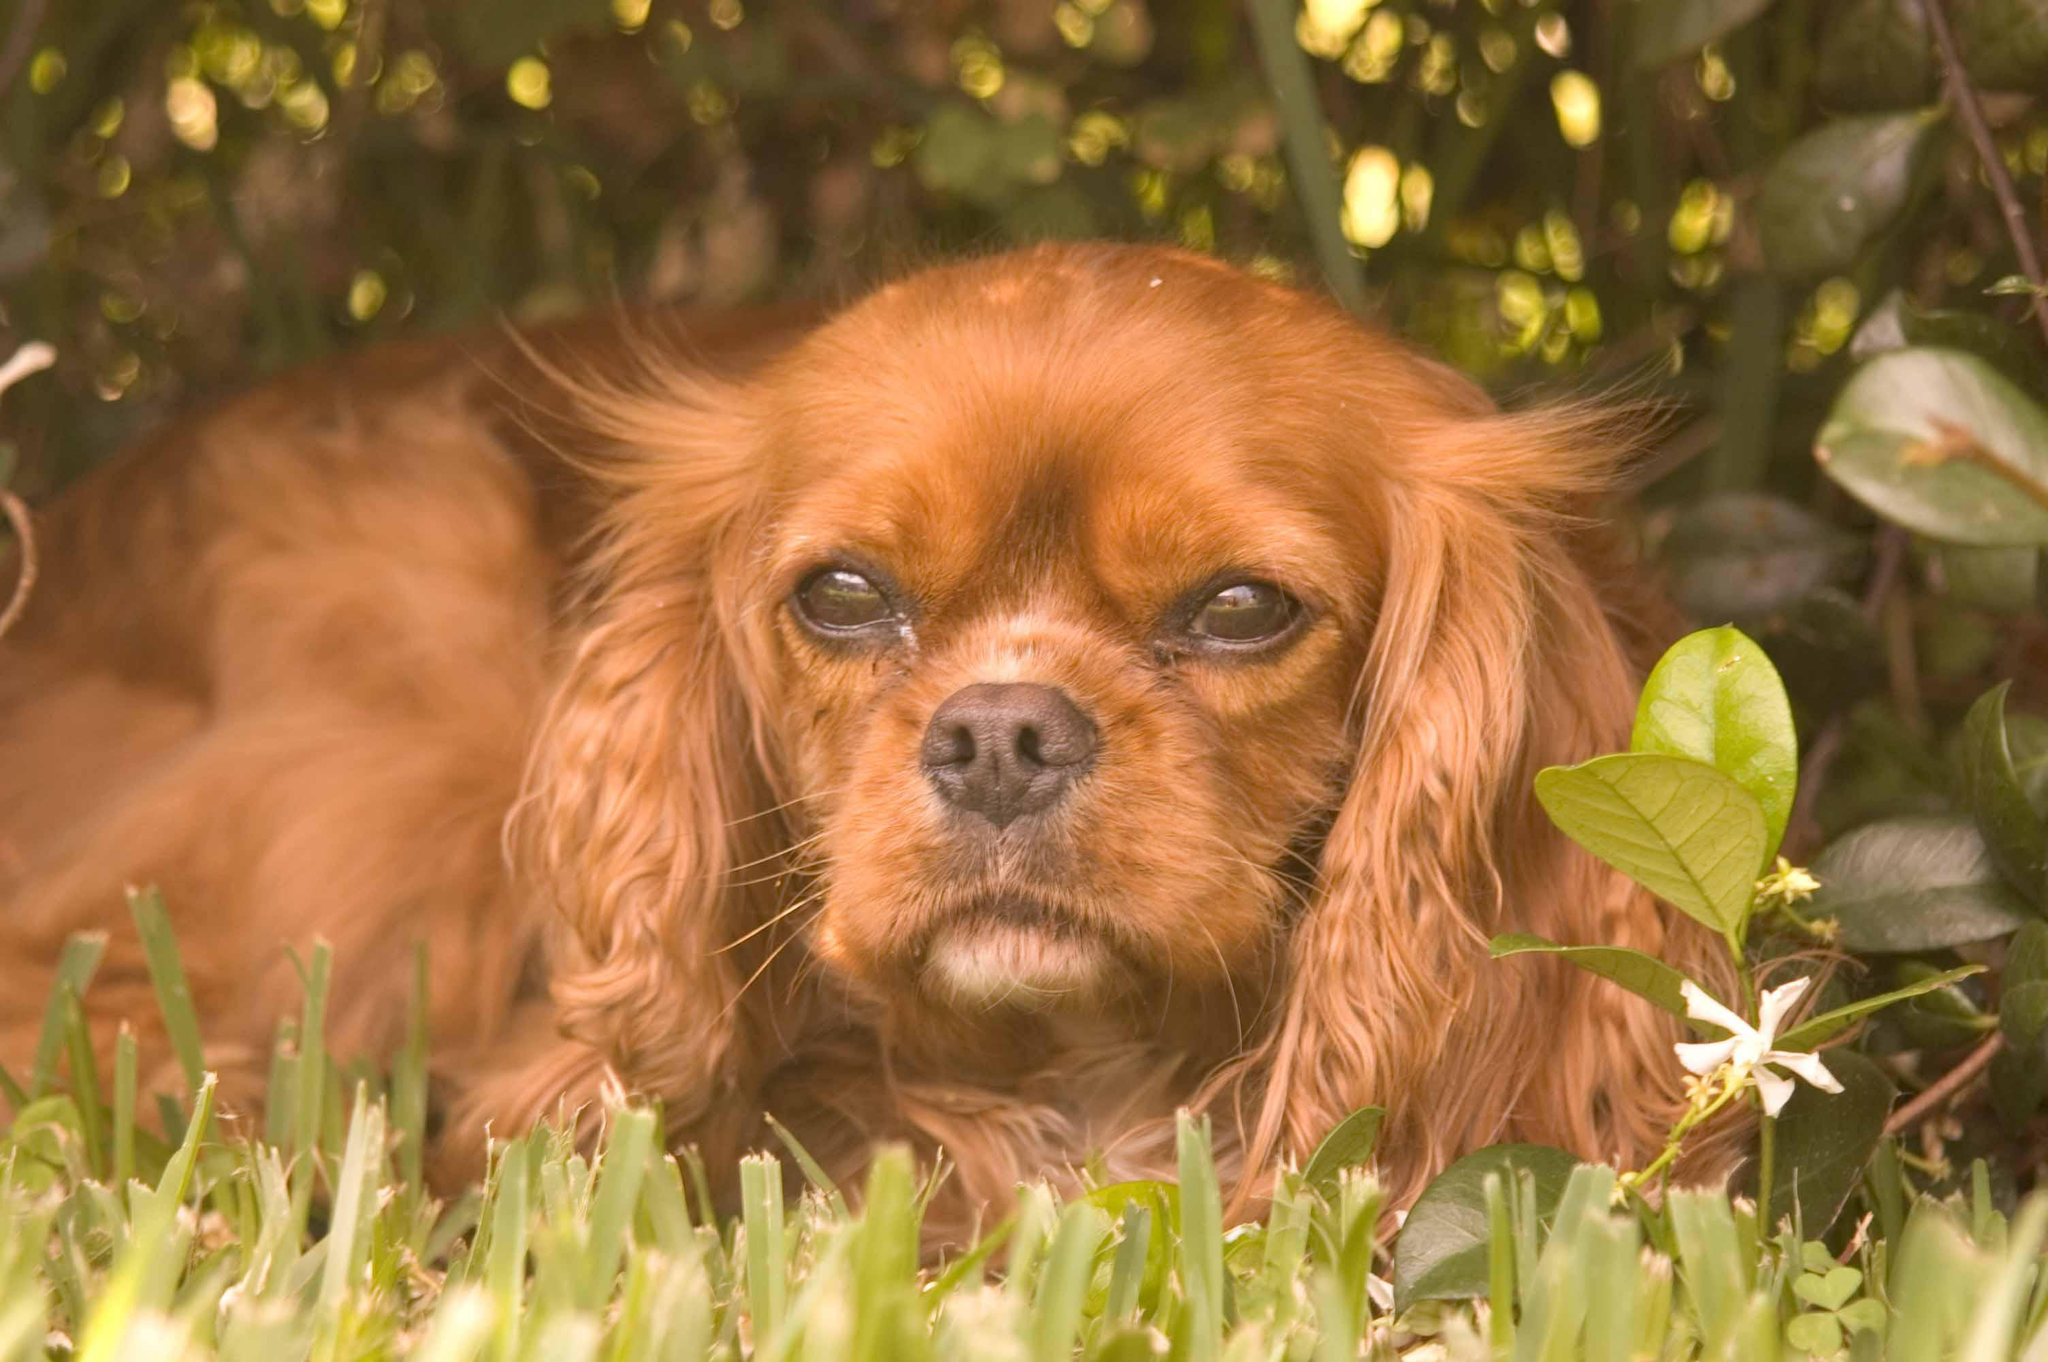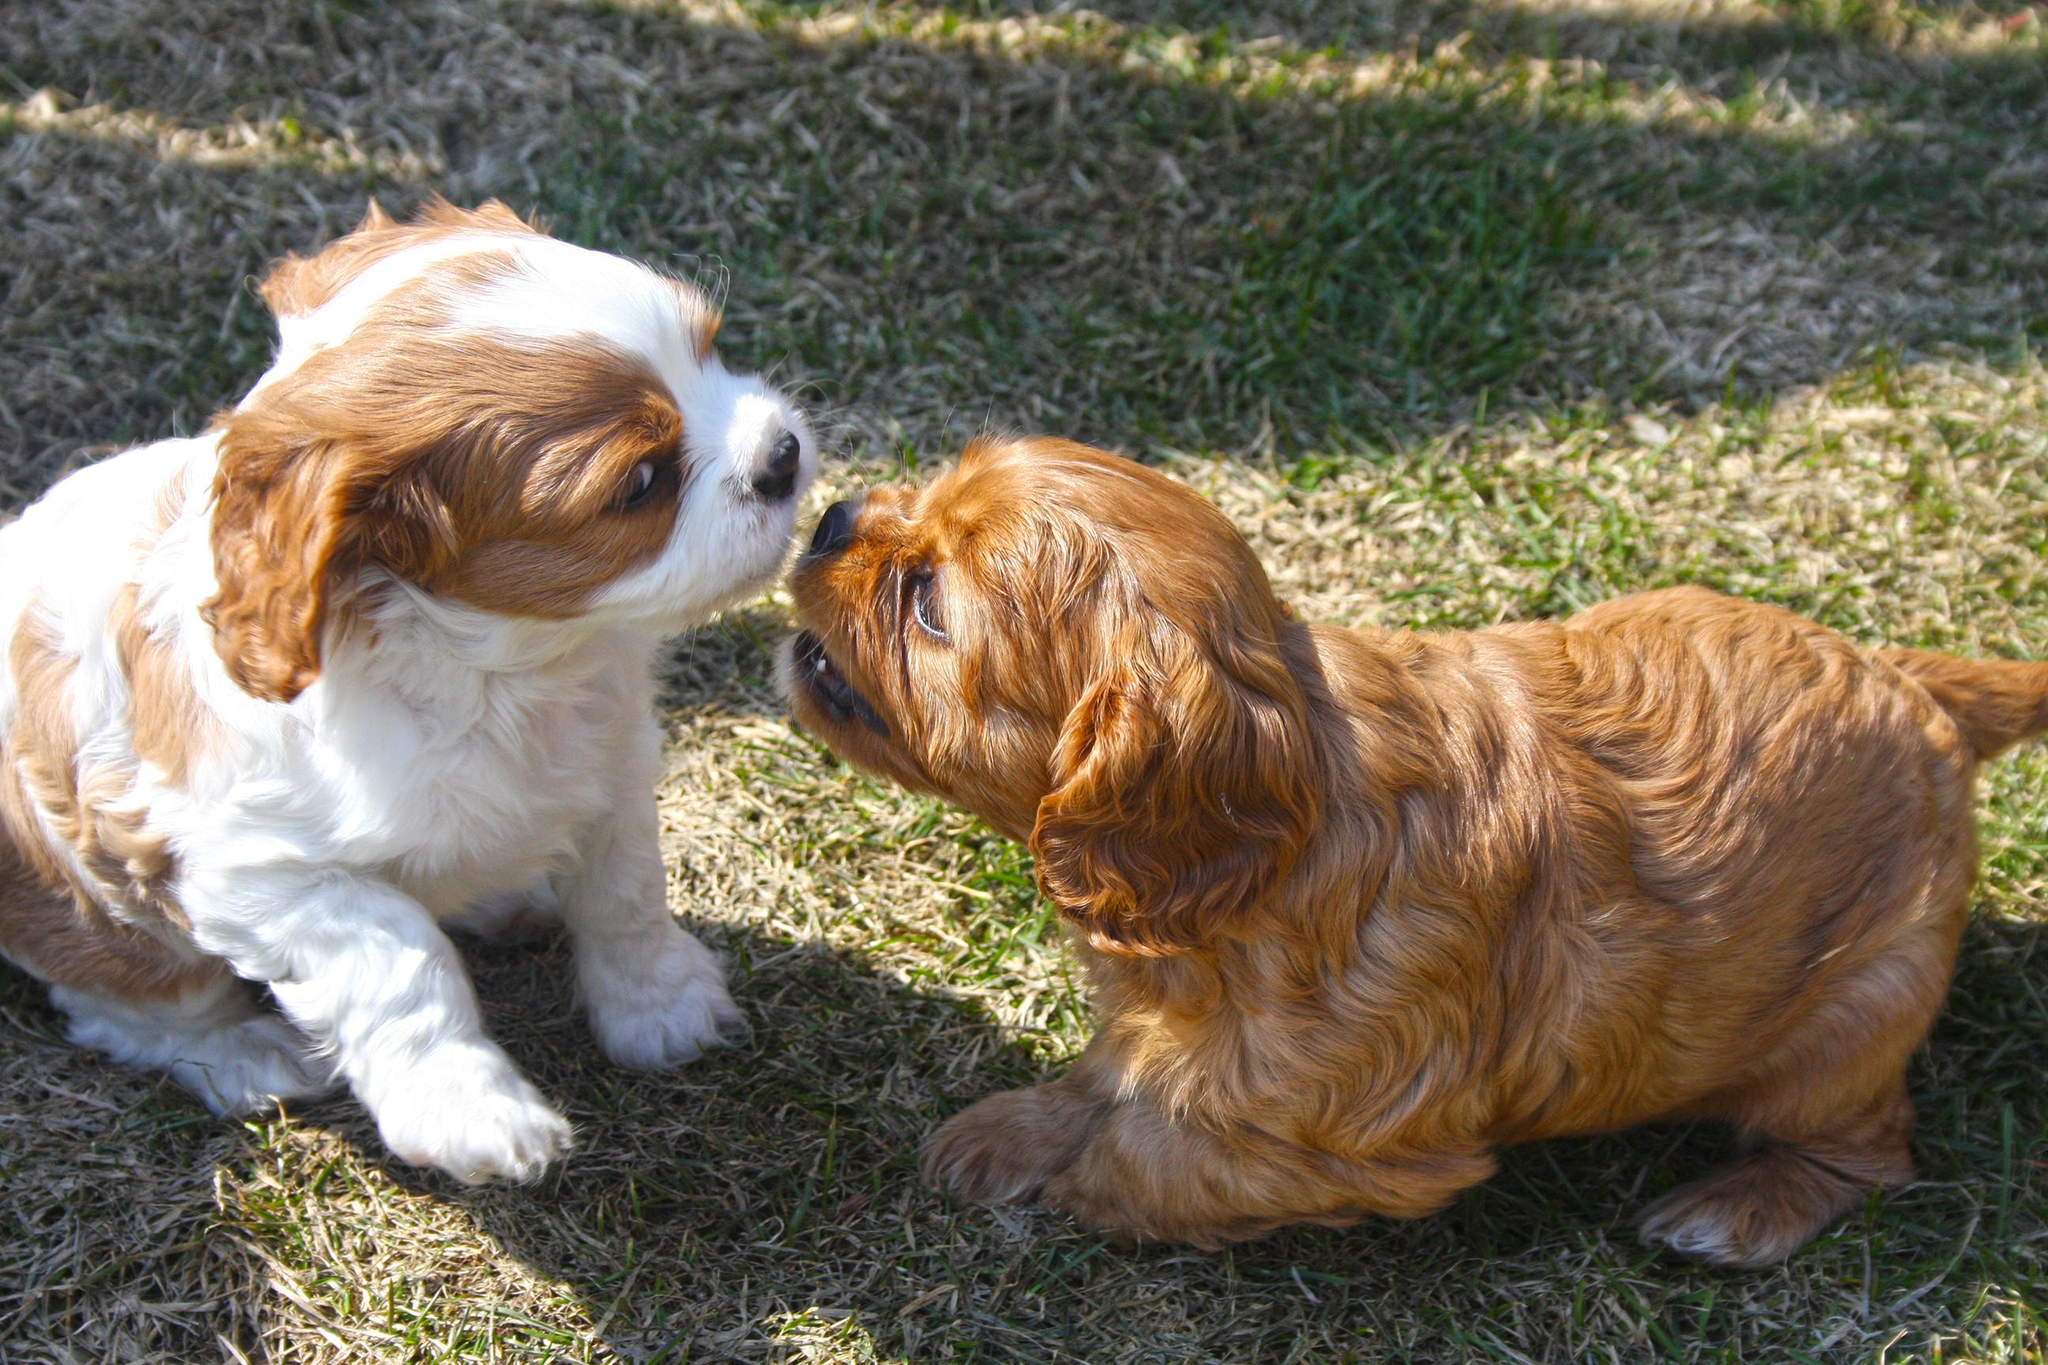The first image is the image on the left, the second image is the image on the right. Given the left and right images, does the statement "An orange spaniel is on the right of an orange-and-white spaniel, and they are face-to-face on the grass." hold true? Answer yes or no. Yes. The first image is the image on the left, the second image is the image on the right. Examine the images to the left and right. Is the description "In one image, a brown dog appears to try and kiss a brown and white dog under its chin" accurate? Answer yes or no. Yes. 